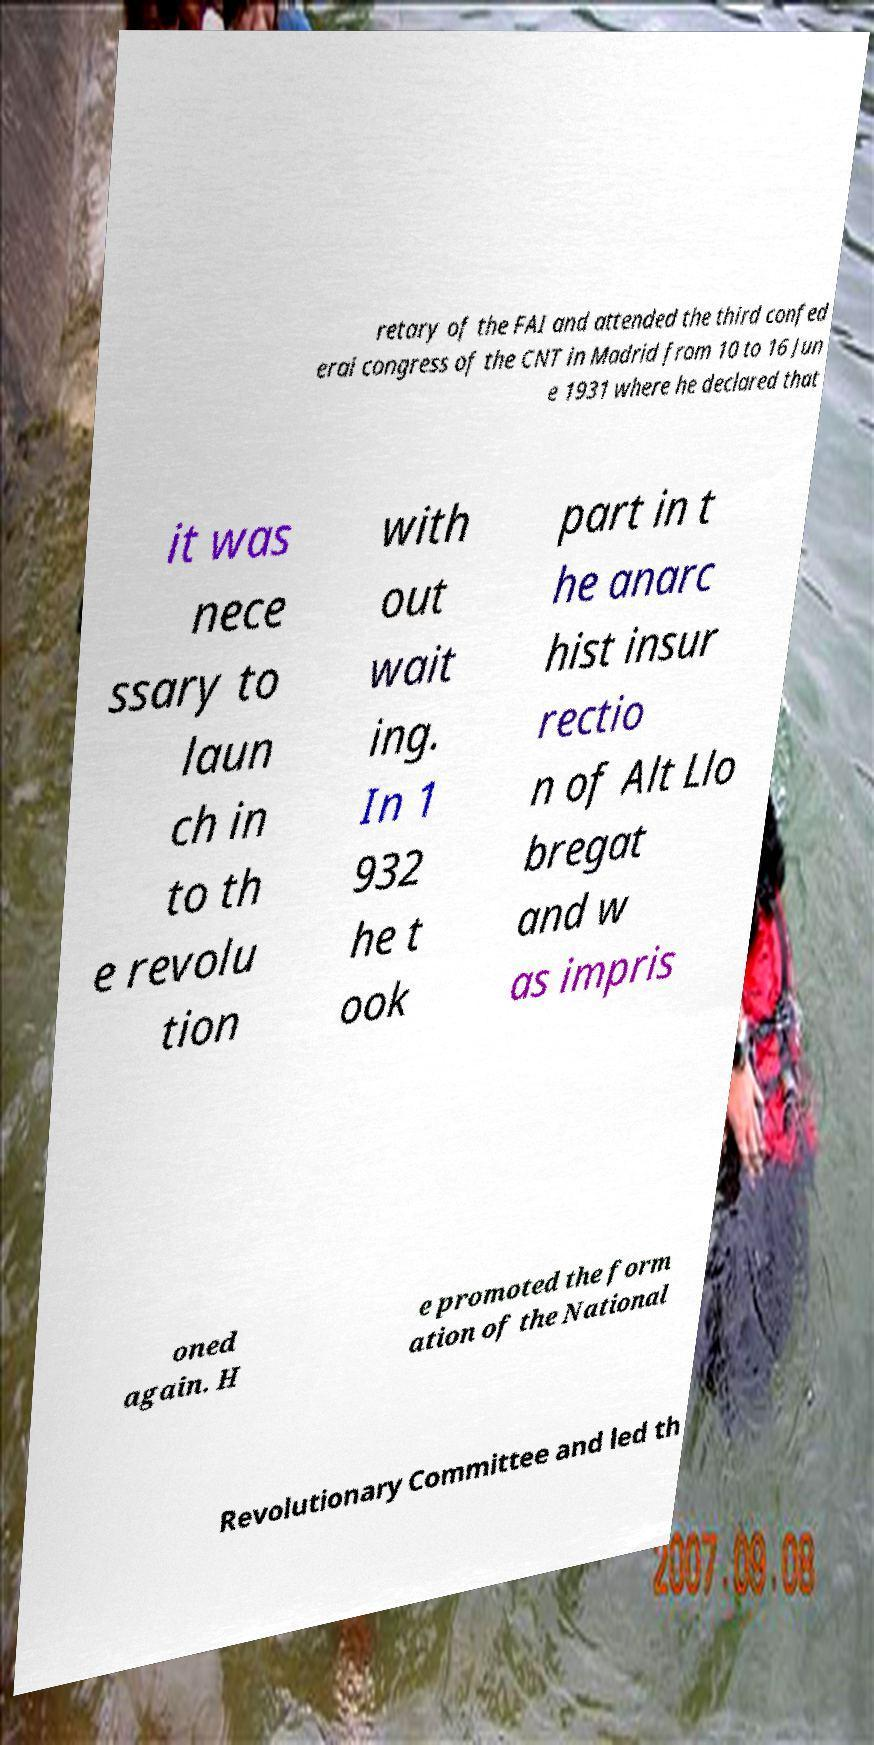Could you assist in decoding the text presented in this image and type it out clearly? retary of the FAI and attended the third confed eral congress of the CNT in Madrid from 10 to 16 Jun e 1931 where he declared that it was nece ssary to laun ch in to th e revolu tion with out wait ing. In 1 932 he t ook part in t he anarc hist insur rectio n of Alt Llo bregat and w as impris oned again. H e promoted the form ation of the National Revolutionary Committee and led th 